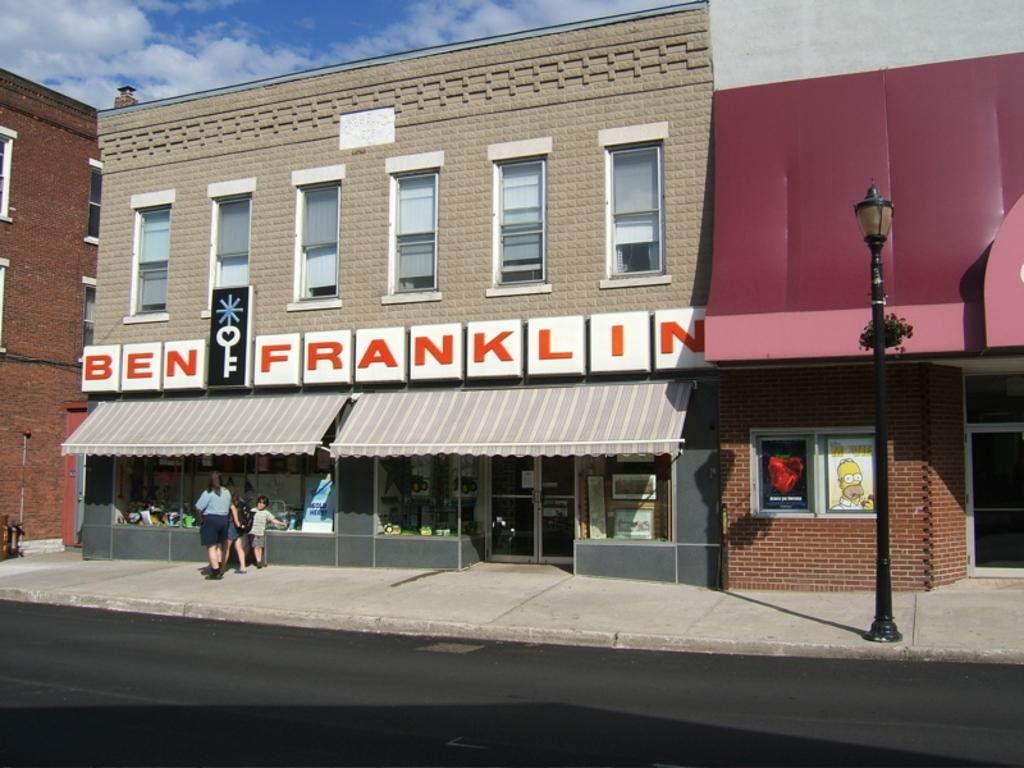Describe this image in one or two sentences. In this image we can see some people standing on the ground. We can also see some buildings with windows, a street pole, some boards with text and pictures on them, the pathway and the sky which looks cloudy. 